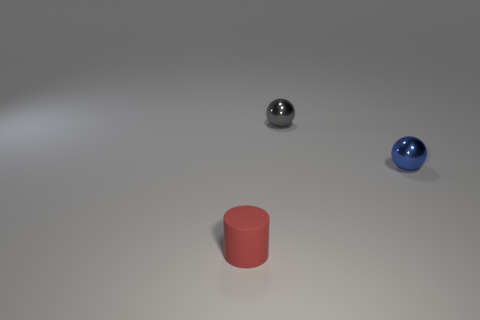What number of brown things have the same material as the tiny gray ball?
Keep it short and to the point. 0. How many blue metal things are the same size as the blue ball?
Provide a short and direct response. 0. The thing to the left of the small object that is behind the tiny sphere that is right of the tiny gray metallic sphere is made of what material?
Offer a terse response. Rubber. What number of objects are blue balls or rubber objects?
Offer a terse response. 2. Is there anything else that is the same material as the tiny blue object?
Provide a short and direct response. Yes. What is the shape of the small red object?
Make the answer very short. Cylinder. There is a tiny thing to the right of the shiny thing that is left of the tiny blue thing; what is its shape?
Your answer should be very brief. Sphere. Is the material of the small ball to the left of the small blue metal sphere the same as the tiny red cylinder?
Offer a terse response. No. How many red things are either tiny cylinders or tiny things?
Your response must be concise. 1. Is there a metal object that has the same color as the cylinder?
Ensure brevity in your answer.  No. 